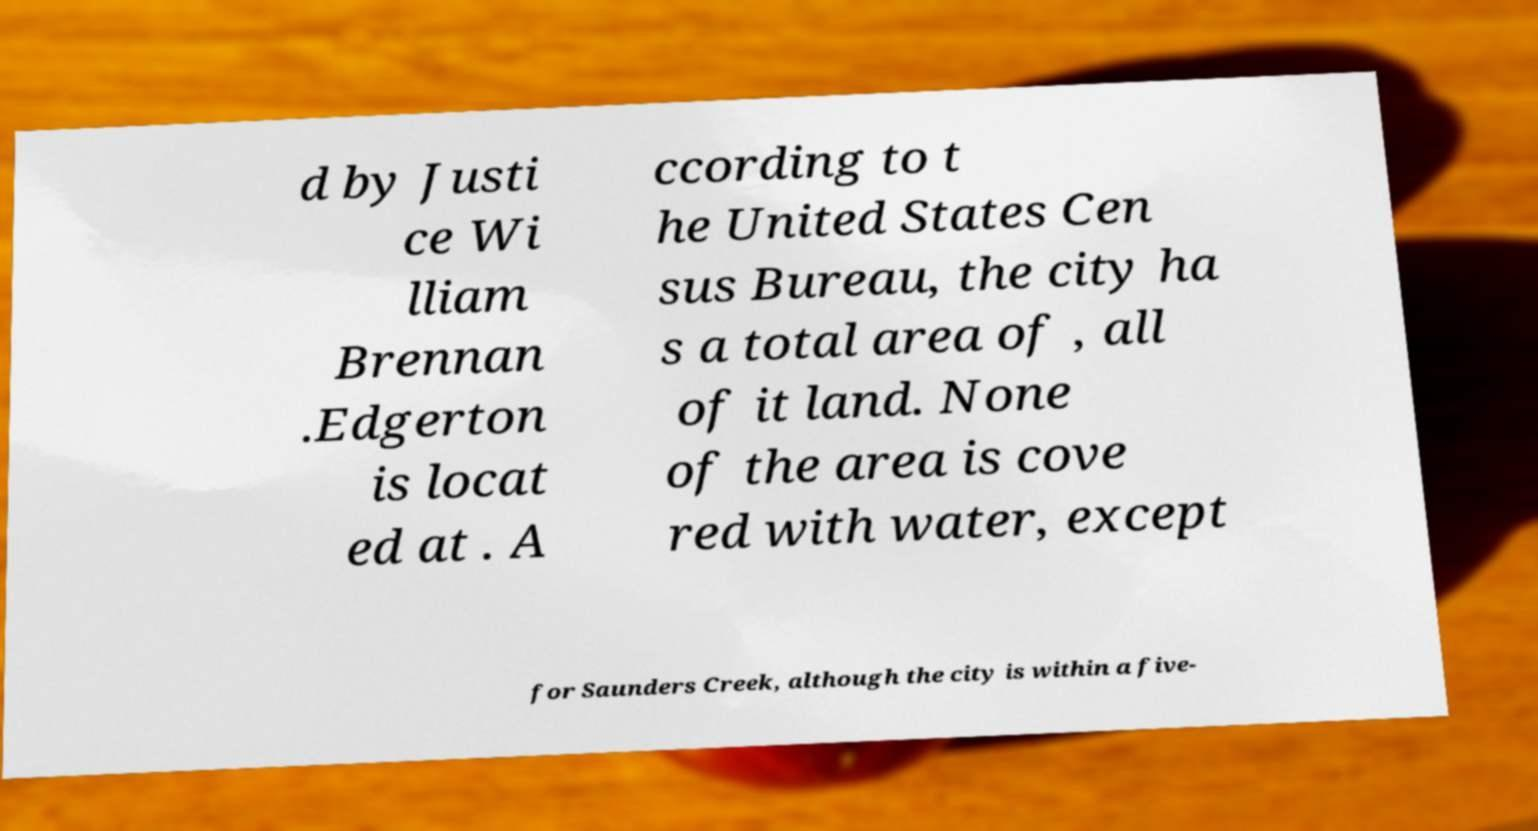For documentation purposes, I need the text within this image transcribed. Could you provide that? d by Justi ce Wi lliam Brennan .Edgerton is locat ed at . A ccording to t he United States Cen sus Bureau, the city ha s a total area of , all of it land. None of the area is cove red with water, except for Saunders Creek, although the city is within a five- 